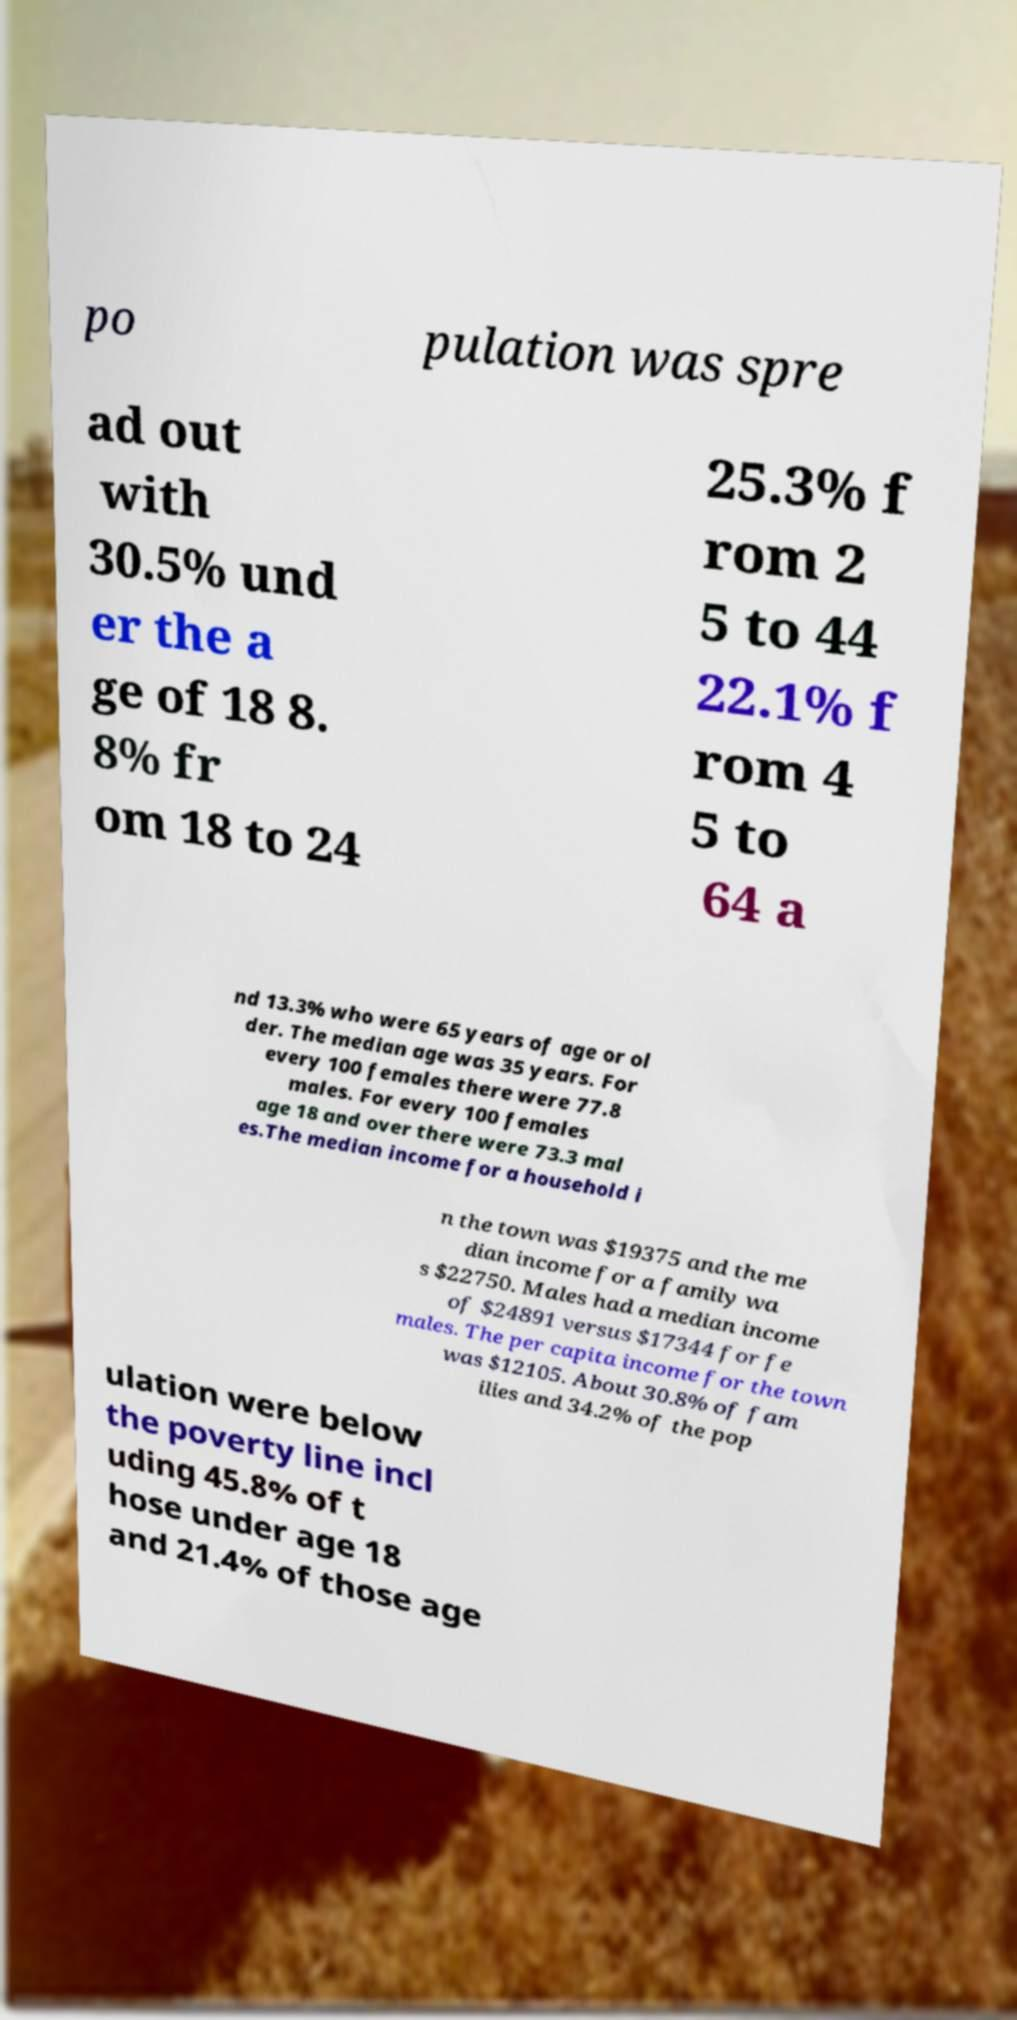Please read and relay the text visible in this image. What does it say? po pulation was spre ad out with 30.5% und er the a ge of 18 8. 8% fr om 18 to 24 25.3% f rom 2 5 to 44 22.1% f rom 4 5 to 64 a nd 13.3% who were 65 years of age or ol der. The median age was 35 years. For every 100 females there were 77.8 males. For every 100 females age 18 and over there were 73.3 mal es.The median income for a household i n the town was $19375 and the me dian income for a family wa s $22750. Males had a median income of $24891 versus $17344 for fe males. The per capita income for the town was $12105. About 30.8% of fam ilies and 34.2% of the pop ulation were below the poverty line incl uding 45.8% of t hose under age 18 and 21.4% of those age 